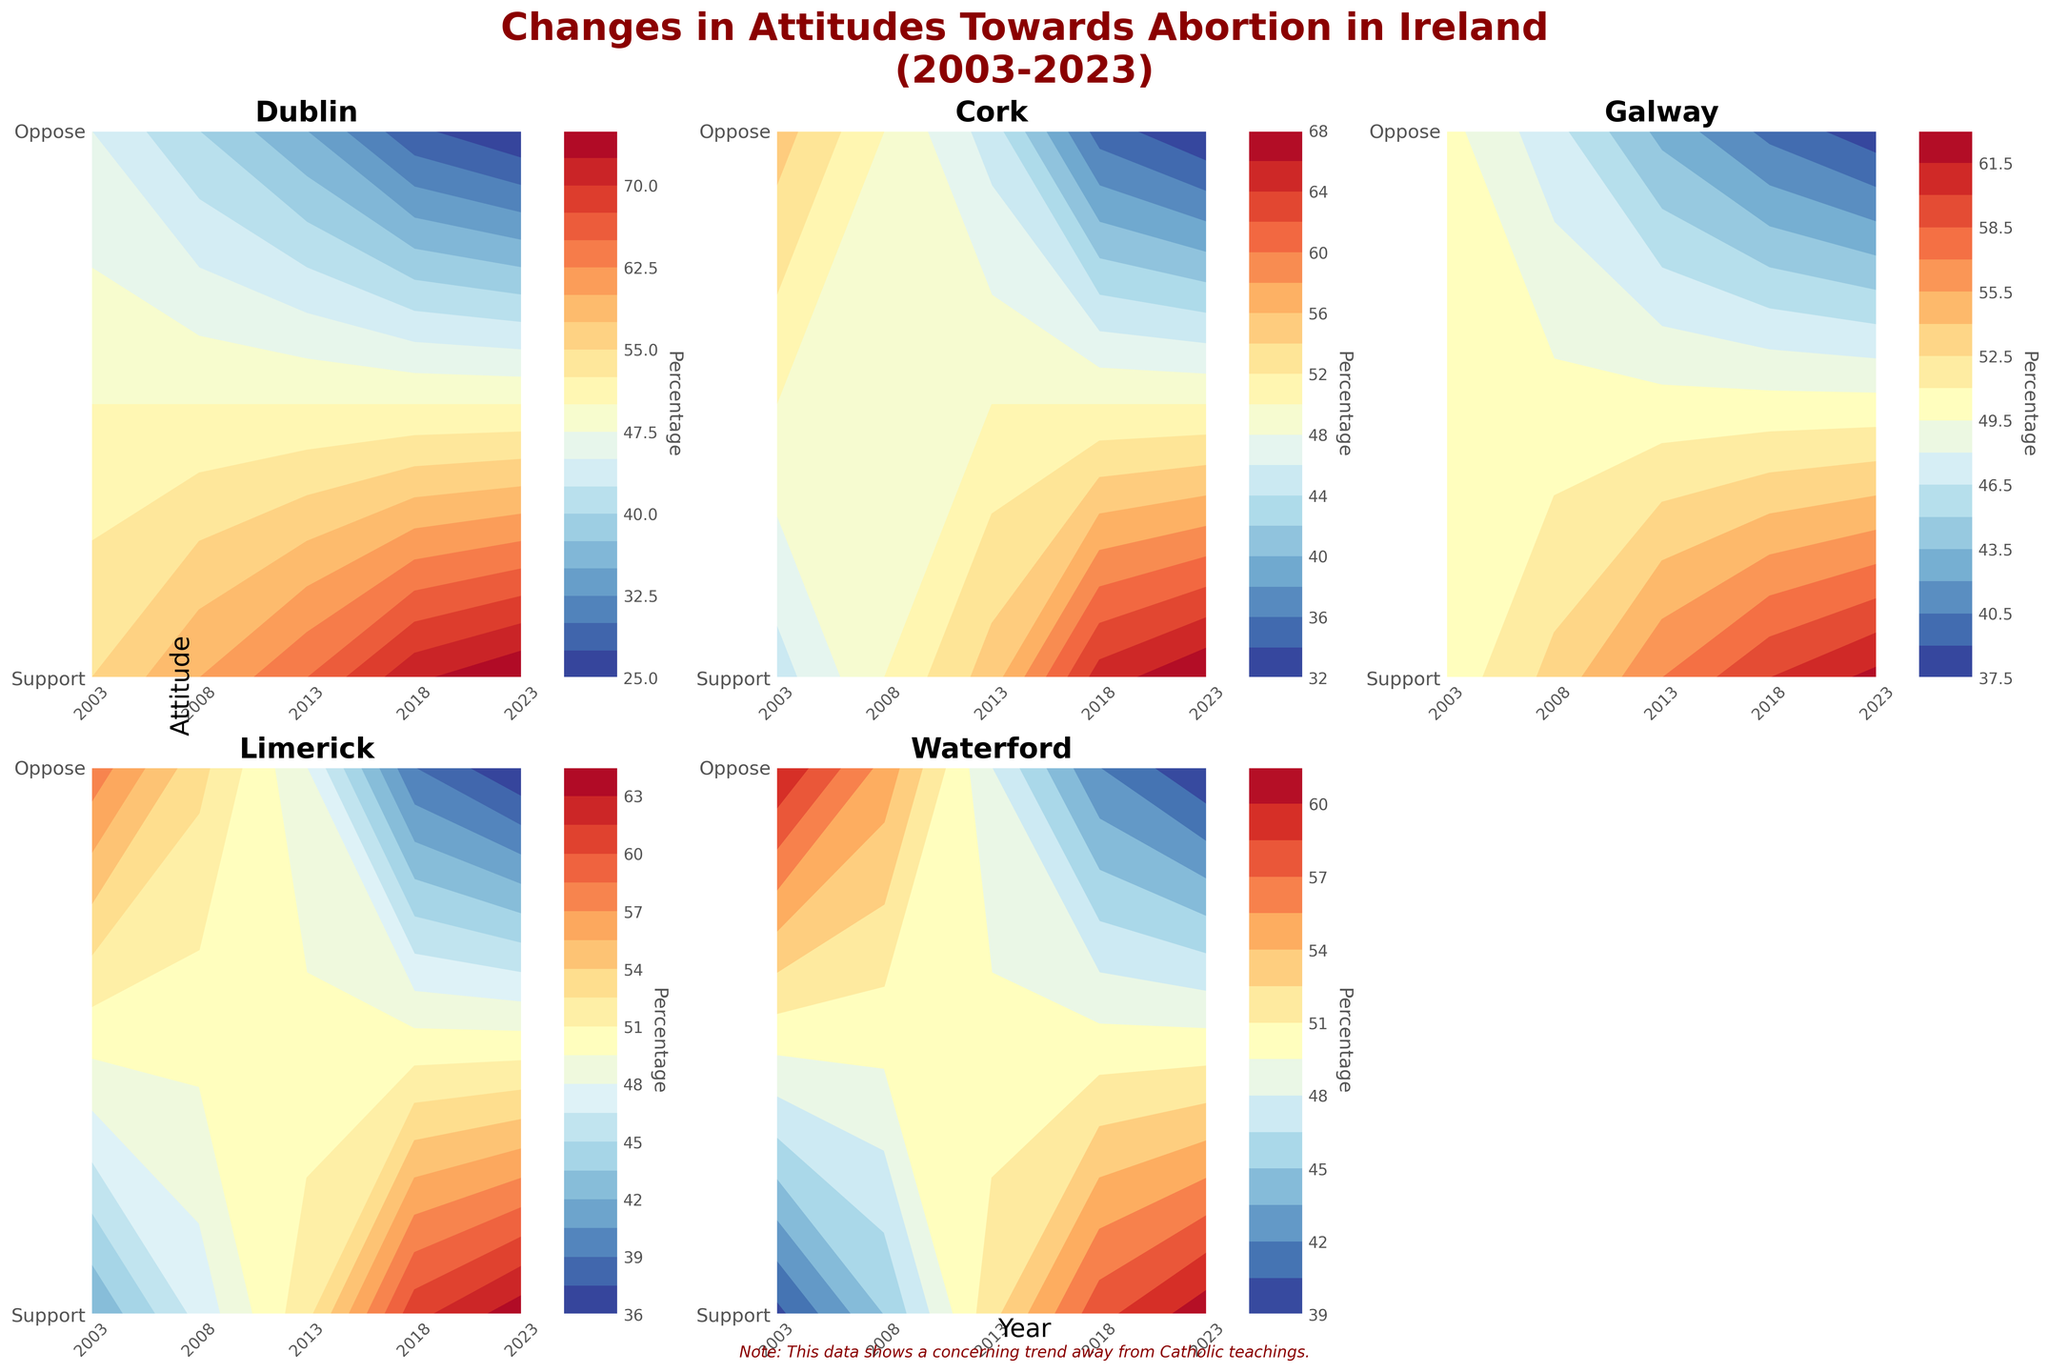What is the overall trend in Dublin's support for abortion from 2003 to 2023? Observing the contour plot for Dublin, the support percentage increases progressively from 2003 to 2023, starting at 55% in 2003 and reaching 75% in 2023.
Answer: Support has increased Which county showed the largest increase in support for abortion over the 20 years? By comparing the changes in support percentages among all counties, the largest increase is seen in Dublin, which went from 55% in 2003 to 75% in 2023, a 20% increase.
Answer: Dublin How did the support for abortion in Cork change between 2018 and 2023? Looking at the contour plot for Cork, support increased from 65% in 2018 to 68% in 2023, showing a 3% increase.
Answer: Increased by 3% Which year did Waterford register a crossing point where support and opposition percentages were equal? In the contour plot for Waterford, the support and opposition percentages are equal (50-50) in 2013.
Answer: 2013 Which county had the lowest support for abortion in 2003? By checking the initial support percentages in the plots, Waterford had the lowest support at 40% in 2003.
Answer: Waterford Between Galway and Limerick, which county had higher support for abortion in 2018? Comparing the contour plots for Galway and Limerick in 2018, Limerick had a higher support percentage at 61% compared to Galway's 60%.
Answer: Limerick How much did the opposition to abortion change in Galway from 2003 to 2023? The opposition percentage in Galway decreased from 50% in 2003 to 38% in 2023, a reduction of 12%.
Answer: Decreased by 12% Which county showed the most dramatic annual increase in support for abortion within the 20-year span? Examining the changes year-by-year in each contour plot, Dublin had the most dramatic annual increase, particularly between 2013 (65%) and 2018 (72%), a 7% increase.
Answer: Dublin Was support for abortion ever lower than opposition in 2023 for any county? Analyzing the 2023 data across all contour plots, opposition was lower than support in all counties.
Answer: No 